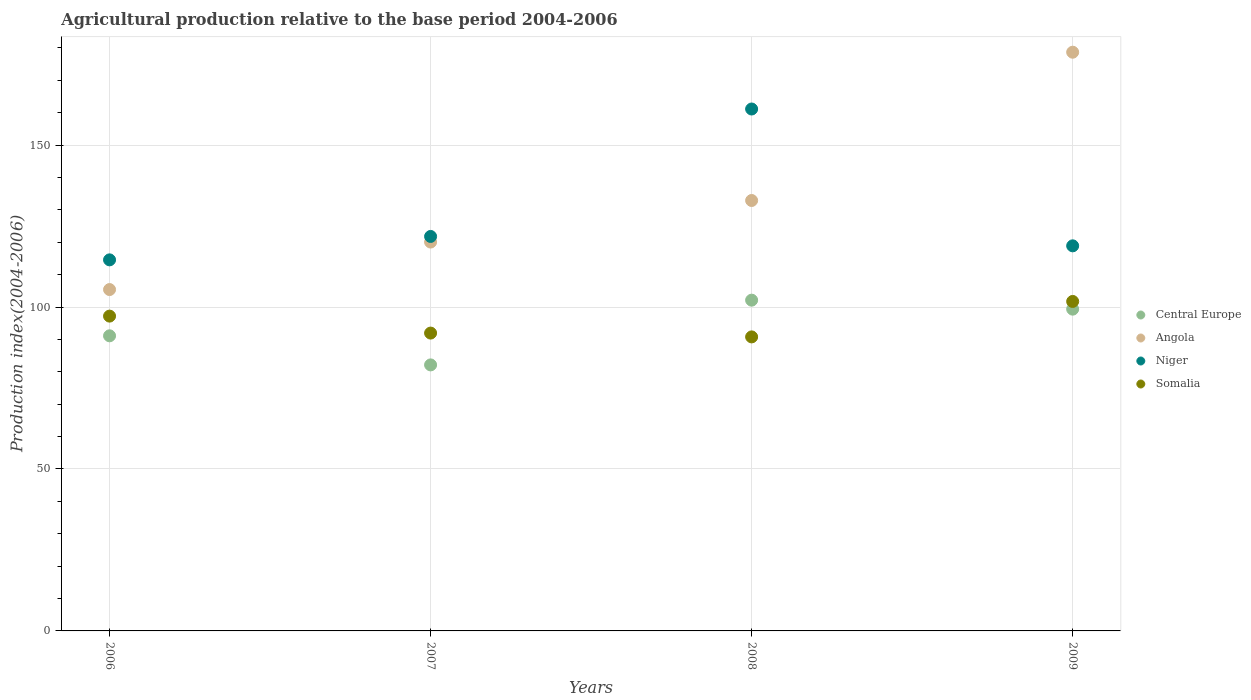How many different coloured dotlines are there?
Provide a short and direct response. 4. What is the agricultural production index in Niger in 2009?
Provide a short and direct response. 118.91. Across all years, what is the maximum agricultural production index in Somalia?
Make the answer very short. 101.74. Across all years, what is the minimum agricultural production index in Niger?
Make the answer very short. 114.58. In which year was the agricultural production index in Somalia maximum?
Make the answer very short. 2009. In which year was the agricultural production index in Angola minimum?
Ensure brevity in your answer.  2006. What is the total agricultural production index in Niger in the graph?
Give a very brief answer. 516.46. What is the difference between the agricultural production index in Somalia in 2007 and that in 2008?
Make the answer very short. 1.18. What is the difference between the agricultural production index in Central Europe in 2008 and the agricultural production index in Somalia in 2007?
Provide a succinct answer. 10.16. What is the average agricultural production index in Central Europe per year?
Make the answer very short. 93.69. In the year 2009, what is the difference between the agricultural production index in Angola and agricultural production index in Niger?
Your response must be concise. 59.79. In how many years, is the agricultural production index in Angola greater than 140?
Offer a very short reply. 1. What is the ratio of the agricultural production index in Niger in 2006 to that in 2009?
Offer a terse response. 0.96. Is the agricultural production index in Somalia in 2006 less than that in 2008?
Give a very brief answer. No. What is the difference between the highest and the second highest agricultural production index in Somalia?
Give a very brief answer. 4.53. What is the difference between the highest and the lowest agricultural production index in Angola?
Offer a very short reply. 73.29. Is it the case that in every year, the sum of the agricultural production index in Niger and agricultural production index in Somalia  is greater than the sum of agricultural production index in Angola and agricultural production index in Central Europe?
Your answer should be compact. No. Is it the case that in every year, the sum of the agricultural production index in Angola and agricultural production index in Central Europe  is greater than the agricultural production index in Somalia?
Your response must be concise. Yes. Does the agricultural production index in Angola monotonically increase over the years?
Your answer should be very brief. Yes. Is the agricultural production index in Niger strictly greater than the agricultural production index in Somalia over the years?
Your response must be concise. Yes. How many dotlines are there?
Offer a terse response. 4. How many years are there in the graph?
Your answer should be compact. 4. Does the graph contain grids?
Provide a succinct answer. Yes. Where does the legend appear in the graph?
Keep it short and to the point. Center right. How are the legend labels stacked?
Provide a short and direct response. Vertical. What is the title of the graph?
Provide a short and direct response. Agricultural production relative to the base period 2004-2006. What is the label or title of the X-axis?
Give a very brief answer. Years. What is the label or title of the Y-axis?
Your answer should be compact. Production index(2004-2006). What is the Production index(2004-2006) of Central Europe in 2006?
Your answer should be compact. 91.13. What is the Production index(2004-2006) in Angola in 2006?
Ensure brevity in your answer.  105.41. What is the Production index(2004-2006) in Niger in 2006?
Your answer should be compact. 114.58. What is the Production index(2004-2006) in Somalia in 2006?
Give a very brief answer. 97.21. What is the Production index(2004-2006) of Central Europe in 2007?
Provide a short and direct response. 82.14. What is the Production index(2004-2006) of Angola in 2007?
Give a very brief answer. 120.08. What is the Production index(2004-2006) in Niger in 2007?
Your answer should be compact. 121.81. What is the Production index(2004-2006) in Somalia in 2007?
Your response must be concise. 91.97. What is the Production index(2004-2006) in Central Europe in 2008?
Your answer should be compact. 102.13. What is the Production index(2004-2006) of Angola in 2008?
Offer a very short reply. 132.91. What is the Production index(2004-2006) in Niger in 2008?
Provide a succinct answer. 161.16. What is the Production index(2004-2006) of Somalia in 2008?
Your answer should be very brief. 90.79. What is the Production index(2004-2006) in Central Europe in 2009?
Make the answer very short. 99.36. What is the Production index(2004-2006) of Angola in 2009?
Provide a succinct answer. 178.7. What is the Production index(2004-2006) in Niger in 2009?
Your answer should be compact. 118.91. What is the Production index(2004-2006) of Somalia in 2009?
Give a very brief answer. 101.74. Across all years, what is the maximum Production index(2004-2006) of Central Europe?
Provide a succinct answer. 102.13. Across all years, what is the maximum Production index(2004-2006) of Angola?
Give a very brief answer. 178.7. Across all years, what is the maximum Production index(2004-2006) of Niger?
Offer a terse response. 161.16. Across all years, what is the maximum Production index(2004-2006) in Somalia?
Offer a terse response. 101.74. Across all years, what is the minimum Production index(2004-2006) of Central Europe?
Provide a succinct answer. 82.14. Across all years, what is the minimum Production index(2004-2006) in Angola?
Give a very brief answer. 105.41. Across all years, what is the minimum Production index(2004-2006) of Niger?
Your response must be concise. 114.58. Across all years, what is the minimum Production index(2004-2006) of Somalia?
Give a very brief answer. 90.79. What is the total Production index(2004-2006) of Central Europe in the graph?
Offer a terse response. 374.76. What is the total Production index(2004-2006) in Angola in the graph?
Ensure brevity in your answer.  537.1. What is the total Production index(2004-2006) of Niger in the graph?
Ensure brevity in your answer.  516.46. What is the total Production index(2004-2006) of Somalia in the graph?
Provide a short and direct response. 381.71. What is the difference between the Production index(2004-2006) in Central Europe in 2006 and that in 2007?
Offer a terse response. 8.98. What is the difference between the Production index(2004-2006) in Angola in 2006 and that in 2007?
Your response must be concise. -14.67. What is the difference between the Production index(2004-2006) in Niger in 2006 and that in 2007?
Your answer should be very brief. -7.23. What is the difference between the Production index(2004-2006) of Somalia in 2006 and that in 2007?
Offer a terse response. 5.24. What is the difference between the Production index(2004-2006) of Central Europe in 2006 and that in 2008?
Give a very brief answer. -11.01. What is the difference between the Production index(2004-2006) of Angola in 2006 and that in 2008?
Your answer should be compact. -27.5. What is the difference between the Production index(2004-2006) of Niger in 2006 and that in 2008?
Your response must be concise. -46.58. What is the difference between the Production index(2004-2006) of Somalia in 2006 and that in 2008?
Your answer should be very brief. 6.42. What is the difference between the Production index(2004-2006) of Central Europe in 2006 and that in 2009?
Offer a terse response. -8.23. What is the difference between the Production index(2004-2006) in Angola in 2006 and that in 2009?
Your answer should be very brief. -73.29. What is the difference between the Production index(2004-2006) in Niger in 2006 and that in 2009?
Your answer should be very brief. -4.33. What is the difference between the Production index(2004-2006) of Somalia in 2006 and that in 2009?
Give a very brief answer. -4.53. What is the difference between the Production index(2004-2006) in Central Europe in 2007 and that in 2008?
Your answer should be compact. -19.99. What is the difference between the Production index(2004-2006) in Angola in 2007 and that in 2008?
Your answer should be compact. -12.83. What is the difference between the Production index(2004-2006) of Niger in 2007 and that in 2008?
Offer a very short reply. -39.35. What is the difference between the Production index(2004-2006) in Somalia in 2007 and that in 2008?
Offer a terse response. 1.18. What is the difference between the Production index(2004-2006) in Central Europe in 2007 and that in 2009?
Keep it short and to the point. -17.22. What is the difference between the Production index(2004-2006) in Angola in 2007 and that in 2009?
Provide a succinct answer. -58.62. What is the difference between the Production index(2004-2006) of Somalia in 2007 and that in 2009?
Offer a terse response. -9.77. What is the difference between the Production index(2004-2006) in Central Europe in 2008 and that in 2009?
Your answer should be very brief. 2.77. What is the difference between the Production index(2004-2006) in Angola in 2008 and that in 2009?
Offer a terse response. -45.79. What is the difference between the Production index(2004-2006) in Niger in 2008 and that in 2009?
Your response must be concise. 42.25. What is the difference between the Production index(2004-2006) in Somalia in 2008 and that in 2009?
Offer a terse response. -10.95. What is the difference between the Production index(2004-2006) of Central Europe in 2006 and the Production index(2004-2006) of Angola in 2007?
Keep it short and to the point. -28.95. What is the difference between the Production index(2004-2006) of Central Europe in 2006 and the Production index(2004-2006) of Niger in 2007?
Offer a terse response. -30.68. What is the difference between the Production index(2004-2006) of Central Europe in 2006 and the Production index(2004-2006) of Somalia in 2007?
Offer a very short reply. -0.84. What is the difference between the Production index(2004-2006) in Angola in 2006 and the Production index(2004-2006) in Niger in 2007?
Provide a short and direct response. -16.4. What is the difference between the Production index(2004-2006) in Angola in 2006 and the Production index(2004-2006) in Somalia in 2007?
Your response must be concise. 13.44. What is the difference between the Production index(2004-2006) in Niger in 2006 and the Production index(2004-2006) in Somalia in 2007?
Offer a very short reply. 22.61. What is the difference between the Production index(2004-2006) of Central Europe in 2006 and the Production index(2004-2006) of Angola in 2008?
Your answer should be compact. -41.78. What is the difference between the Production index(2004-2006) in Central Europe in 2006 and the Production index(2004-2006) in Niger in 2008?
Make the answer very short. -70.03. What is the difference between the Production index(2004-2006) of Central Europe in 2006 and the Production index(2004-2006) of Somalia in 2008?
Keep it short and to the point. 0.34. What is the difference between the Production index(2004-2006) in Angola in 2006 and the Production index(2004-2006) in Niger in 2008?
Make the answer very short. -55.75. What is the difference between the Production index(2004-2006) of Angola in 2006 and the Production index(2004-2006) of Somalia in 2008?
Your answer should be very brief. 14.62. What is the difference between the Production index(2004-2006) in Niger in 2006 and the Production index(2004-2006) in Somalia in 2008?
Provide a succinct answer. 23.79. What is the difference between the Production index(2004-2006) in Central Europe in 2006 and the Production index(2004-2006) in Angola in 2009?
Ensure brevity in your answer.  -87.57. What is the difference between the Production index(2004-2006) of Central Europe in 2006 and the Production index(2004-2006) of Niger in 2009?
Provide a short and direct response. -27.78. What is the difference between the Production index(2004-2006) of Central Europe in 2006 and the Production index(2004-2006) of Somalia in 2009?
Provide a short and direct response. -10.61. What is the difference between the Production index(2004-2006) in Angola in 2006 and the Production index(2004-2006) in Somalia in 2009?
Offer a very short reply. 3.67. What is the difference between the Production index(2004-2006) in Niger in 2006 and the Production index(2004-2006) in Somalia in 2009?
Offer a terse response. 12.84. What is the difference between the Production index(2004-2006) in Central Europe in 2007 and the Production index(2004-2006) in Angola in 2008?
Make the answer very short. -50.77. What is the difference between the Production index(2004-2006) of Central Europe in 2007 and the Production index(2004-2006) of Niger in 2008?
Offer a very short reply. -79.02. What is the difference between the Production index(2004-2006) in Central Europe in 2007 and the Production index(2004-2006) in Somalia in 2008?
Keep it short and to the point. -8.65. What is the difference between the Production index(2004-2006) of Angola in 2007 and the Production index(2004-2006) of Niger in 2008?
Ensure brevity in your answer.  -41.08. What is the difference between the Production index(2004-2006) of Angola in 2007 and the Production index(2004-2006) of Somalia in 2008?
Your answer should be compact. 29.29. What is the difference between the Production index(2004-2006) of Niger in 2007 and the Production index(2004-2006) of Somalia in 2008?
Provide a succinct answer. 31.02. What is the difference between the Production index(2004-2006) in Central Europe in 2007 and the Production index(2004-2006) in Angola in 2009?
Offer a terse response. -96.56. What is the difference between the Production index(2004-2006) of Central Europe in 2007 and the Production index(2004-2006) of Niger in 2009?
Offer a terse response. -36.77. What is the difference between the Production index(2004-2006) of Central Europe in 2007 and the Production index(2004-2006) of Somalia in 2009?
Provide a short and direct response. -19.6. What is the difference between the Production index(2004-2006) of Angola in 2007 and the Production index(2004-2006) of Niger in 2009?
Provide a succinct answer. 1.17. What is the difference between the Production index(2004-2006) in Angola in 2007 and the Production index(2004-2006) in Somalia in 2009?
Your response must be concise. 18.34. What is the difference between the Production index(2004-2006) in Niger in 2007 and the Production index(2004-2006) in Somalia in 2009?
Offer a terse response. 20.07. What is the difference between the Production index(2004-2006) in Central Europe in 2008 and the Production index(2004-2006) in Angola in 2009?
Offer a terse response. -76.57. What is the difference between the Production index(2004-2006) in Central Europe in 2008 and the Production index(2004-2006) in Niger in 2009?
Offer a very short reply. -16.78. What is the difference between the Production index(2004-2006) in Central Europe in 2008 and the Production index(2004-2006) in Somalia in 2009?
Give a very brief answer. 0.39. What is the difference between the Production index(2004-2006) in Angola in 2008 and the Production index(2004-2006) in Niger in 2009?
Make the answer very short. 14. What is the difference between the Production index(2004-2006) in Angola in 2008 and the Production index(2004-2006) in Somalia in 2009?
Your answer should be compact. 31.17. What is the difference between the Production index(2004-2006) of Niger in 2008 and the Production index(2004-2006) of Somalia in 2009?
Your answer should be compact. 59.42. What is the average Production index(2004-2006) of Central Europe per year?
Your answer should be very brief. 93.69. What is the average Production index(2004-2006) in Angola per year?
Provide a short and direct response. 134.28. What is the average Production index(2004-2006) of Niger per year?
Make the answer very short. 129.12. What is the average Production index(2004-2006) in Somalia per year?
Ensure brevity in your answer.  95.43. In the year 2006, what is the difference between the Production index(2004-2006) in Central Europe and Production index(2004-2006) in Angola?
Give a very brief answer. -14.28. In the year 2006, what is the difference between the Production index(2004-2006) of Central Europe and Production index(2004-2006) of Niger?
Make the answer very short. -23.45. In the year 2006, what is the difference between the Production index(2004-2006) in Central Europe and Production index(2004-2006) in Somalia?
Provide a short and direct response. -6.08. In the year 2006, what is the difference between the Production index(2004-2006) of Angola and Production index(2004-2006) of Niger?
Your answer should be very brief. -9.17. In the year 2006, what is the difference between the Production index(2004-2006) in Niger and Production index(2004-2006) in Somalia?
Make the answer very short. 17.37. In the year 2007, what is the difference between the Production index(2004-2006) of Central Europe and Production index(2004-2006) of Angola?
Offer a terse response. -37.94. In the year 2007, what is the difference between the Production index(2004-2006) of Central Europe and Production index(2004-2006) of Niger?
Offer a terse response. -39.67. In the year 2007, what is the difference between the Production index(2004-2006) in Central Europe and Production index(2004-2006) in Somalia?
Keep it short and to the point. -9.83. In the year 2007, what is the difference between the Production index(2004-2006) in Angola and Production index(2004-2006) in Niger?
Your response must be concise. -1.73. In the year 2007, what is the difference between the Production index(2004-2006) in Angola and Production index(2004-2006) in Somalia?
Offer a very short reply. 28.11. In the year 2007, what is the difference between the Production index(2004-2006) of Niger and Production index(2004-2006) of Somalia?
Your answer should be very brief. 29.84. In the year 2008, what is the difference between the Production index(2004-2006) in Central Europe and Production index(2004-2006) in Angola?
Provide a succinct answer. -30.78. In the year 2008, what is the difference between the Production index(2004-2006) of Central Europe and Production index(2004-2006) of Niger?
Offer a terse response. -59.03. In the year 2008, what is the difference between the Production index(2004-2006) in Central Europe and Production index(2004-2006) in Somalia?
Give a very brief answer. 11.34. In the year 2008, what is the difference between the Production index(2004-2006) of Angola and Production index(2004-2006) of Niger?
Provide a short and direct response. -28.25. In the year 2008, what is the difference between the Production index(2004-2006) of Angola and Production index(2004-2006) of Somalia?
Your answer should be compact. 42.12. In the year 2008, what is the difference between the Production index(2004-2006) of Niger and Production index(2004-2006) of Somalia?
Ensure brevity in your answer.  70.37. In the year 2009, what is the difference between the Production index(2004-2006) of Central Europe and Production index(2004-2006) of Angola?
Offer a terse response. -79.34. In the year 2009, what is the difference between the Production index(2004-2006) of Central Europe and Production index(2004-2006) of Niger?
Provide a short and direct response. -19.55. In the year 2009, what is the difference between the Production index(2004-2006) in Central Europe and Production index(2004-2006) in Somalia?
Ensure brevity in your answer.  -2.38. In the year 2009, what is the difference between the Production index(2004-2006) in Angola and Production index(2004-2006) in Niger?
Offer a terse response. 59.79. In the year 2009, what is the difference between the Production index(2004-2006) of Angola and Production index(2004-2006) of Somalia?
Your answer should be very brief. 76.96. In the year 2009, what is the difference between the Production index(2004-2006) of Niger and Production index(2004-2006) of Somalia?
Offer a very short reply. 17.17. What is the ratio of the Production index(2004-2006) in Central Europe in 2006 to that in 2007?
Give a very brief answer. 1.11. What is the ratio of the Production index(2004-2006) in Angola in 2006 to that in 2007?
Offer a very short reply. 0.88. What is the ratio of the Production index(2004-2006) of Niger in 2006 to that in 2007?
Your response must be concise. 0.94. What is the ratio of the Production index(2004-2006) in Somalia in 2006 to that in 2007?
Keep it short and to the point. 1.06. What is the ratio of the Production index(2004-2006) in Central Europe in 2006 to that in 2008?
Provide a short and direct response. 0.89. What is the ratio of the Production index(2004-2006) of Angola in 2006 to that in 2008?
Provide a succinct answer. 0.79. What is the ratio of the Production index(2004-2006) in Niger in 2006 to that in 2008?
Your answer should be very brief. 0.71. What is the ratio of the Production index(2004-2006) of Somalia in 2006 to that in 2008?
Ensure brevity in your answer.  1.07. What is the ratio of the Production index(2004-2006) in Central Europe in 2006 to that in 2009?
Your response must be concise. 0.92. What is the ratio of the Production index(2004-2006) of Angola in 2006 to that in 2009?
Make the answer very short. 0.59. What is the ratio of the Production index(2004-2006) of Niger in 2006 to that in 2009?
Provide a succinct answer. 0.96. What is the ratio of the Production index(2004-2006) in Somalia in 2006 to that in 2009?
Make the answer very short. 0.96. What is the ratio of the Production index(2004-2006) of Central Europe in 2007 to that in 2008?
Your response must be concise. 0.8. What is the ratio of the Production index(2004-2006) of Angola in 2007 to that in 2008?
Offer a terse response. 0.9. What is the ratio of the Production index(2004-2006) of Niger in 2007 to that in 2008?
Ensure brevity in your answer.  0.76. What is the ratio of the Production index(2004-2006) of Somalia in 2007 to that in 2008?
Offer a very short reply. 1.01. What is the ratio of the Production index(2004-2006) in Central Europe in 2007 to that in 2009?
Your answer should be compact. 0.83. What is the ratio of the Production index(2004-2006) in Angola in 2007 to that in 2009?
Your response must be concise. 0.67. What is the ratio of the Production index(2004-2006) of Niger in 2007 to that in 2009?
Provide a succinct answer. 1.02. What is the ratio of the Production index(2004-2006) in Somalia in 2007 to that in 2009?
Provide a succinct answer. 0.9. What is the ratio of the Production index(2004-2006) of Central Europe in 2008 to that in 2009?
Your answer should be very brief. 1.03. What is the ratio of the Production index(2004-2006) of Angola in 2008 to that in 2009?
Ensure brevity in your answer.  0.74. What is the ratio of the Production index(2004-2006) in Niger in 2008 to that in 2009?
Ensure brevity in your answer.  1.36. What is the ratio of the Production index(2004-2006) in Somalia in 2008 to that in 2009?
Provide a succinct answer. 0.89. What is the difference between the highest and the second highest Production index(2004-2006) in Central Europe?
Your answer should be compact. 2.77. What is the difference between the highest and the second highest Production index(2004-2006) of Angola?
Keep it short and to the point. 45.79. What is the difference between the highest and the second highest Production index(2004-2006) in Niger?
Offer a very short reply. 39.35. What is the difference between the highest and the second highest Production index(2004-2006) of Somalia?
Offer a terse response. 4.53. What is the difference between the highest and the lowest Production index(2004-2006) in Central Europe?
Your answer should be very brief. 19.99. What is the difference between the highest and the lowest Production index(2004-2006) of Angola?
Give a very brief answer. 73.29. What is the difference between the highest and the lowest Production index(2004-2006) in Niger?
Your response must be concise. 46.58. What is the difference between the highest and the lowest Production index(2004-2006) in Somalia?
Your answer should be very brief. 10.95. 